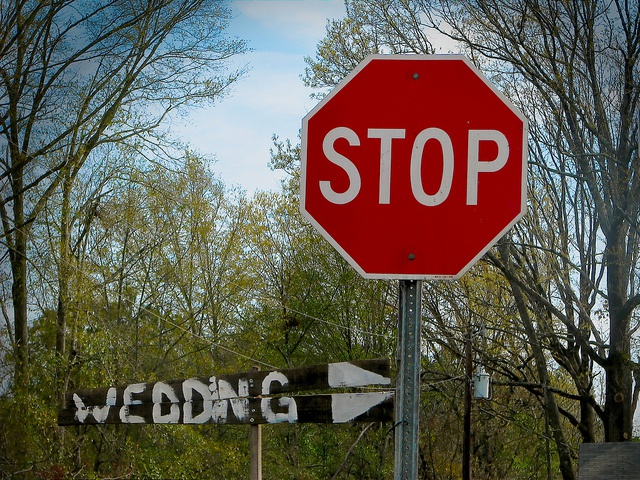Describe the objects in this image and their specific colors. I can see a stop sign in gray, maroon, darkgray, and brown tones in this image. 